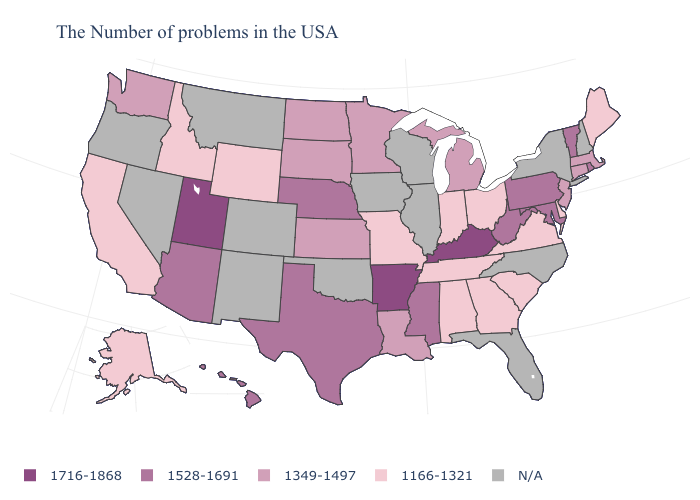Does the map have missing data?
Be succinct. Yes. What is the value of Maine?
Answer briefly. 1166-1321. What is the highest value in the Northeast ?
Answer briefly. 1528-1691. What is the value of Virginia?
Keep it brief. 1166-1321. Name the states that have a value in the range 1166-1321?
Keep it brief. Maine, Delaware, Virginia, South Carolina, Ohio, Georgia, Indiana, Alabama, Tennessee, Missouri, Wyoming, Idaho, California, Alaska. Name the states that have a value in the range N/A?
Quick response, please. New Hampshire, New York, North Carolina, Florida, Wisconsin, Illinois, Iowa, Oklahoma, Colorado, New Mexico, Montana, Nevada, Oregon. What is the highest value in the Northeast ?
Concise answer only. 1528-1691. What is the highest value in states that border Rhode Island?
Give a very brief answer. 1349-1497. What is the value of Pennsylvania?
Answer briefly. 1528-1691. Name the states that have a value in the range N/A?
Short answer required. New Hampshire, New York, North Carolina, Florida, Wisconsin, Illinois, Iowa, Oklahoma, Colorado, New Mexico, Montana, Nevada, Oregon. What is the highest value in states that border Arkansas?
Short answer required. 1528-1691. Name the states that have a value in the range 1716-1868?
Answer briefly. Kentucky, Arkansas, Utah. What is the value of Alaska?
Concise answer only. 1166-1321. What is the highest value in the West ?
Be succinct. 1716-1868. What is the lowest value in the Northeast?
Answer briefly. 1166-1321. 